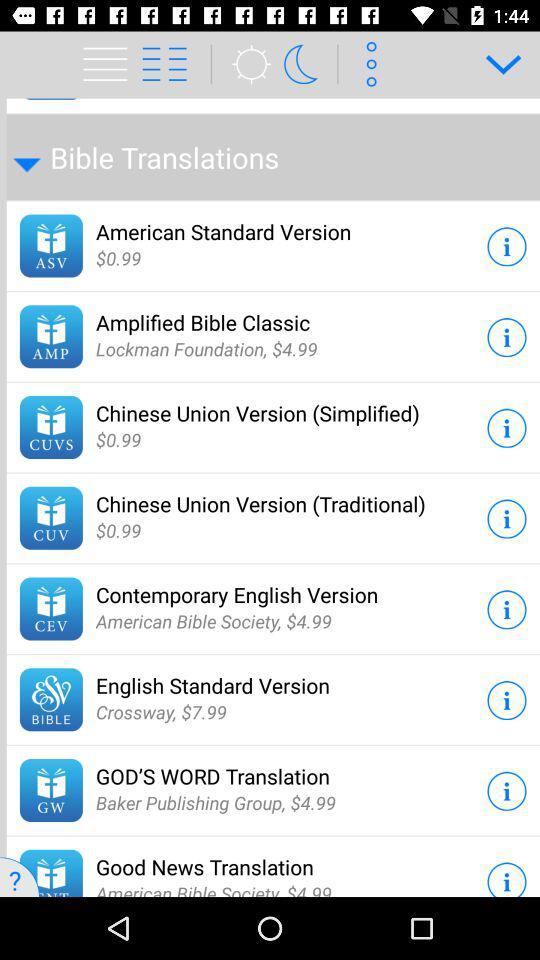How many Bible translations are available for less than $5?
Answer the question using a single word or phrase. 7 